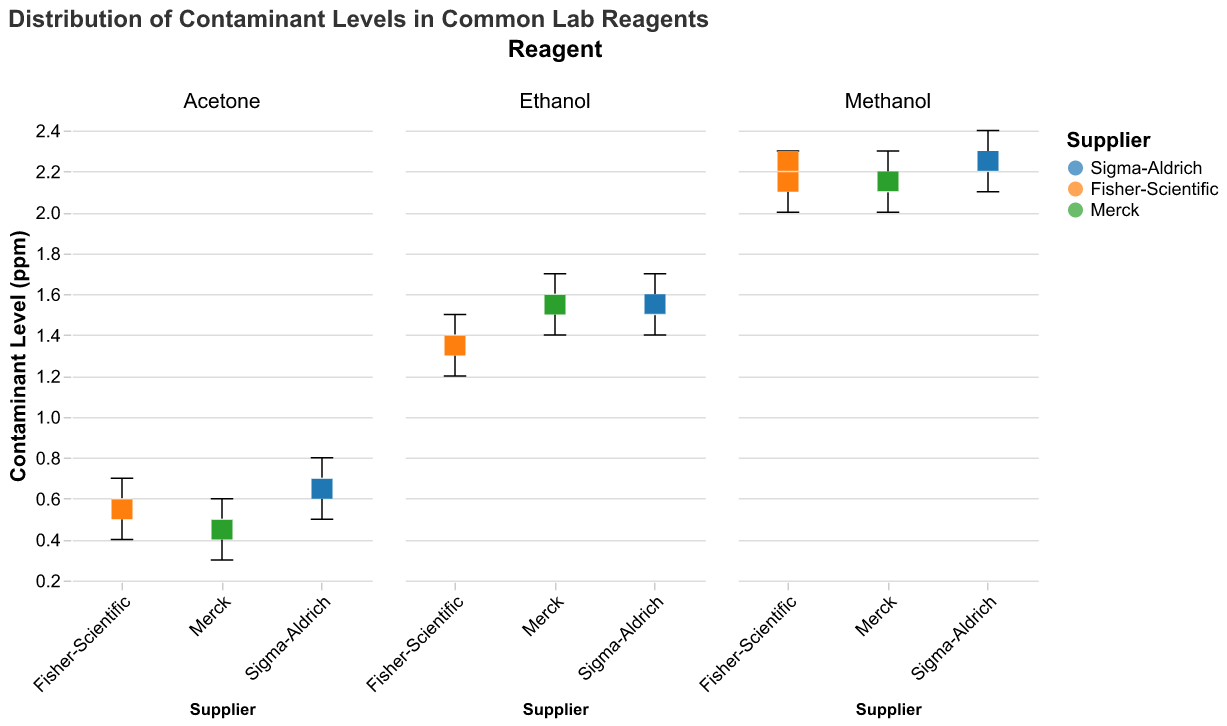What's the title of the figure? The title is located at the top of the figure and provides an overview.
Answer: Distribution of Contaminant Levels in Common Lab Reagents Which supplier has the highest median contaminant level in Ethanol? To determine this, compare the median lines in the box plots for Ethanol across different suppliers.
Answer: Sigma-Aldrich Which reagent has the largest range of contaminant levels for Fisher-Scientific? Observe the length of the whiskers in the box plots for different reagents from Fisher-Scientific and identify the one with the longest whiskers.
Answer: Methanol What is the median contaminant level for Sigma-Aldrich Acetone? Look at the position of the white line inside the box plot for Sigma-Aldrich Acetone.
Answer: 0.7 ppm Which reagent from Merck has the smallest median contaminant level? Compare the white lines (median) in the box plots of different reagents from Merck and identify the smallest value.
Answer: Acetone How does the median contaminant level of Merck's Methanol compare to that of Sigma-Aldrich's Methanol? Compare the white median lines in the box plots for Methanol from both Merck and Sigma-Aldrich.
Answer: Equal What is the interquartile range (IQR) for Fisher-Scientific Acetone? To find the IQR, locate the top and bottom edges of the box for Fisher-Scientific Acetone and calculate the difference between the 75th and 25th percentiles.
Answer: 0.2 ppm Which supplier shows the greatest variability in contaminant levels across all reagents? Assess the overall spread of the box plots and whiskers across all reagents for each supplier.
Answer: Sigma-Aldrich For Ethanol, which supplier has the most consistent (least variable) contaminant levels? Check the length of the whiskers and the height of the boxes in the Ethanol plots for each supplier to find the one with the smallest range and IQR.
Answer: Fisher-Scientific Is the median contaminant level of Fisher-Scientific Acetone greater than that of Merck Acetone? Compare the positions of the white median lines for Fisher-Scientific Acetone and Merck Acetone.
Answer: Yes 